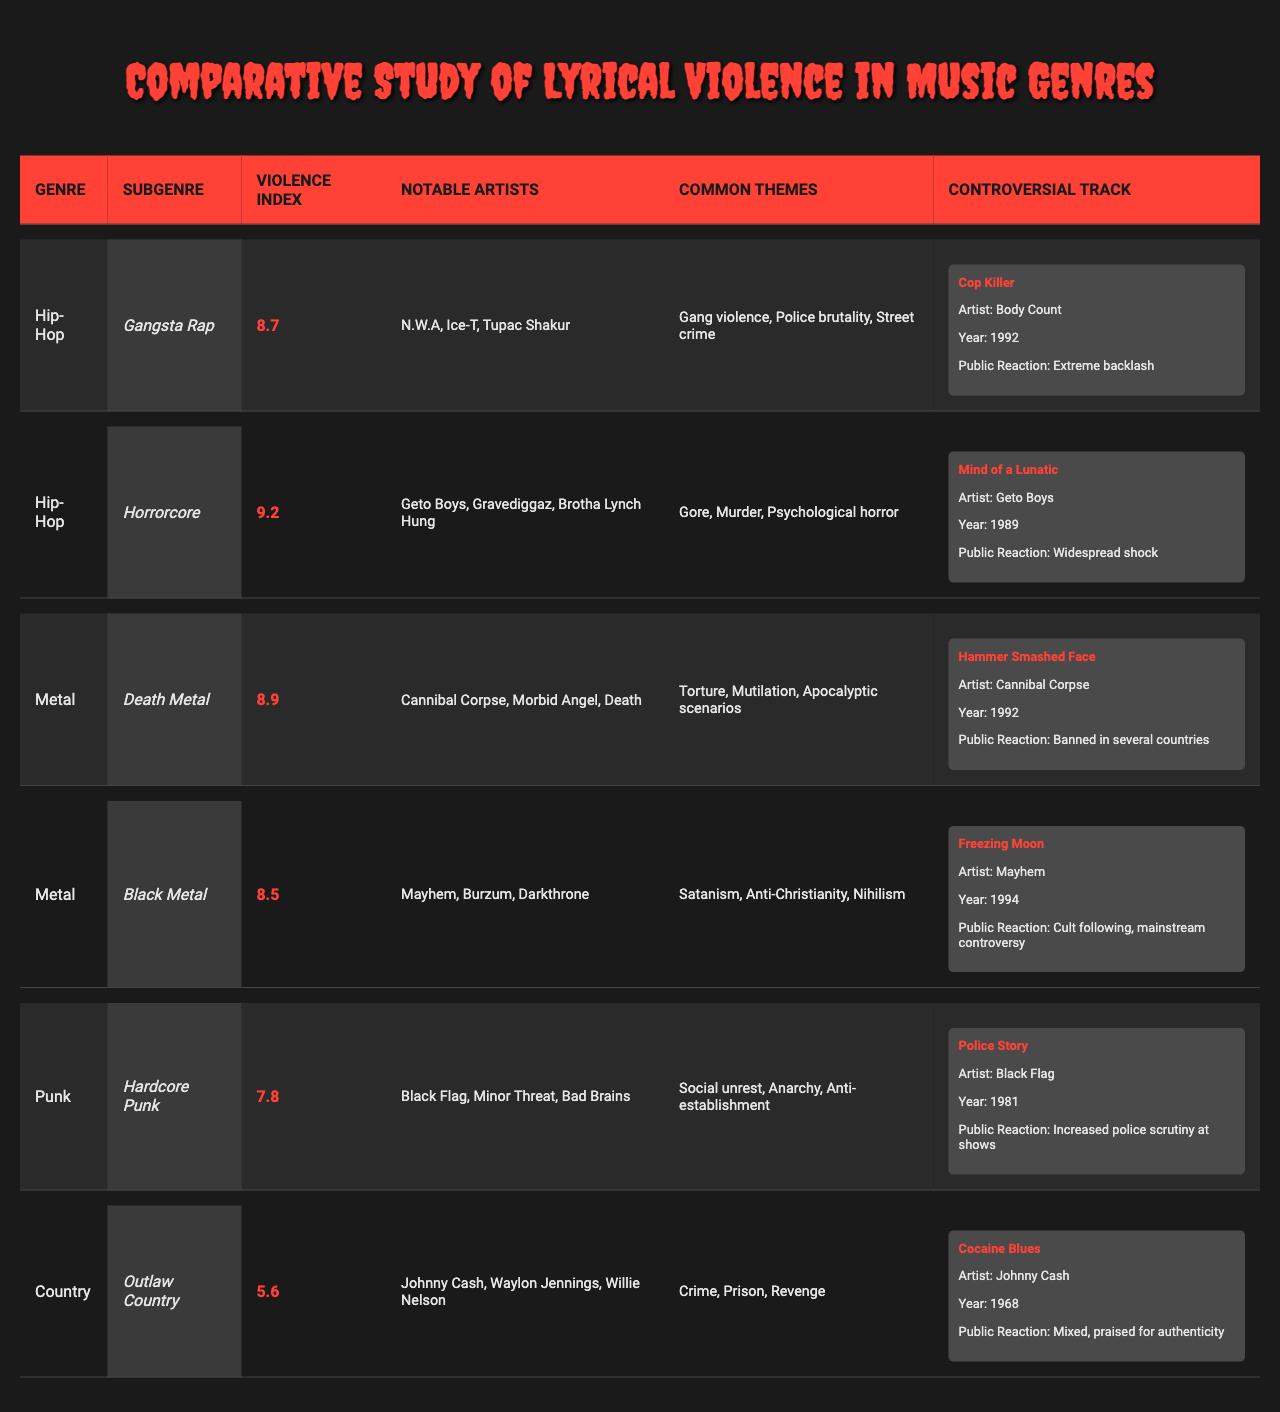What is the highest Violence Index among the subgenres? The highest Violence Index is 9.2 for the Horrorcore subgenre in Hip-Hop.
Answer: 9.2 Which genre has the lowest Violence Index? The lowest Violence Index is 5.6, which belongs to the Outlaw Country subgenre in Country.
Answer: 5.6 List one Notable Artist from the Hardcore Punk subgenre. The notable artists from Hardcore Punk include Black Flag.
Answer: Black Flag How many subgenres of Metal are listed in the table? There are two subgenres of Metal listed: Death Metal and Black Metal.
Answer: 2 True or False: The controversial track “Cocaine Blues” is from the Hip-Hop genre. “Cocaine Blues” is from the Outlaw Country subgenre, not Hip-Hop.
Answer: False What common theme is associated with the Gangsta Rap subgenre? One of the common themes associated with Gangsta Rap is "Police brutality."
Answer: Police brutality What is the average Violence Index of Hip-Hop subgenres? The Violence Index values for Hip-Hop are 8.7 (Gangsta Rap) and 9.2 (Horrorcore). The average is (8.7 + 9.2) / 2 = 8.95.
Answer: 8.95 Which genre has more Notable Artists mentioned in the table, Metal or Punk? Metal has more notable artists (6 total) compared to Punk which has 3. The notable artists for Metal include Cannibal Corpse, Morbid Angel, Death, Mayhem, Burzum, and Darkthrone.
Answer: Metal The controversial track “Mind of a Lunatic” was released in what year? “Mind of a Lunatic” was released in 1989, as cited under the Horrorcore subgenre in the table.
Answer: 1989 What were the public reactions for “Cop Killer”? The public reaction for “Cop Killer” is described as "Extreme backlash."
Answer: Extreme backlash If we compare the Violence Index of Death Metal and Hardcore Punk, which is higher? The Violence Index of Death Metal is 8.9, while Hardcore Punk has 7.8, making Death Metal higher.
Answer: Death Metal is higher 